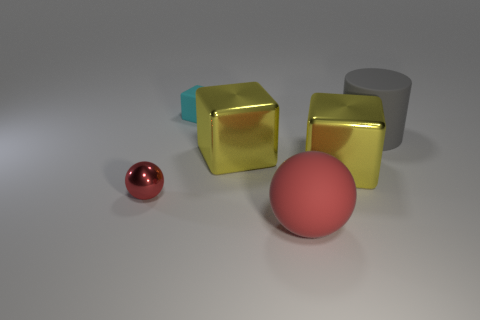Subtract all gray spheres. How many yellow blocks are left? 2 Subtract all large blocks. How many blocks are left? 1 Add 1 small gray matte cubes. How many objects exist? 7 Subtract all balls. How many objects are left? 4 Add 1 large red balls. How many large red balls are left? 2 Add 6 green matte blocks. How many green matte blocks exist? 6 Subtract 0 gray balls. How many objects are left? 6 Subtract all large yellow matte things. Subtract all metallic objects. How many objects are left? 3 